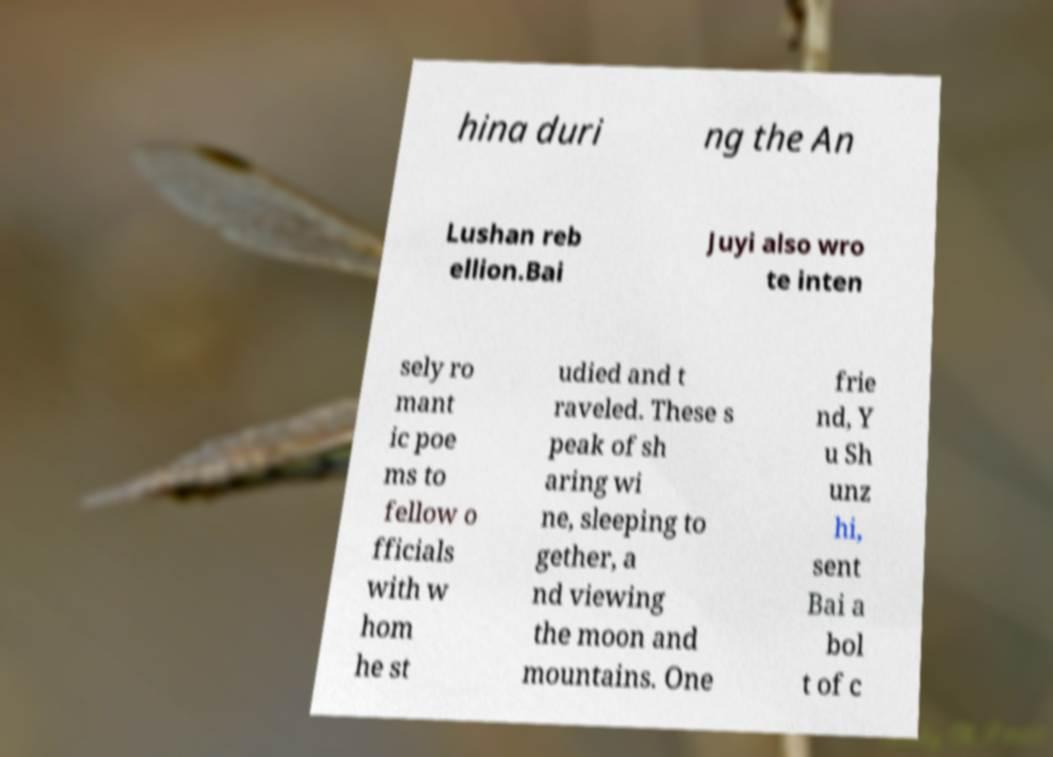Please read and relay the text visible in this image. What does it say? hina duri ng the An Lushan reb ellion.Bai Juyi also wro te inten sely ro mant ic poe ms to fellow o fficials with w hom he st udied and t raveled. These s peak of sh aring wi ne, sleeping to gether, a nd viewing the moon and mountains. One frie nd, Y u Sh unz hi, sent Bai a bol t of c 